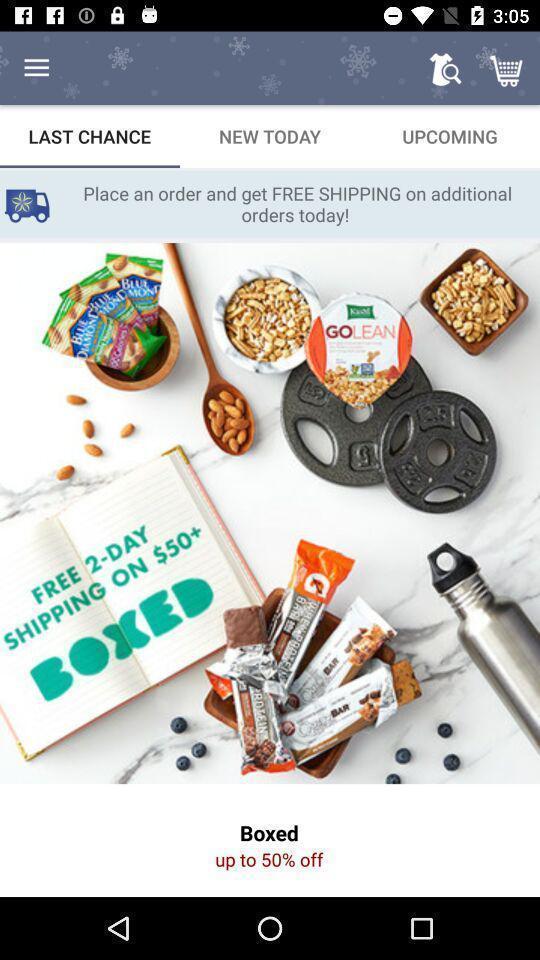Provide a description of this screenshot. Page displaying various options in shopping application. 